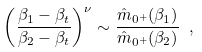Convert formula to latex. <formula><loc_0><loc_0><loc_500><loc_500>\left ( \frac { \beta _ { 1 } - \beta _ { t } } { \beta _ { 2 } - \beta _ { t } } \right ) ^ { \nu } \sim \frac { \hat { m } _ { 0 ^ { + } } ( \beta _ { 1 } ) } { \hat { m } _ { 0 ^ { + } } ( \beta _ { 2 } ) } \ ,</formula> 